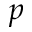<formula> <loc_0><loc_0><loc_500><loc_500>p</formula> 